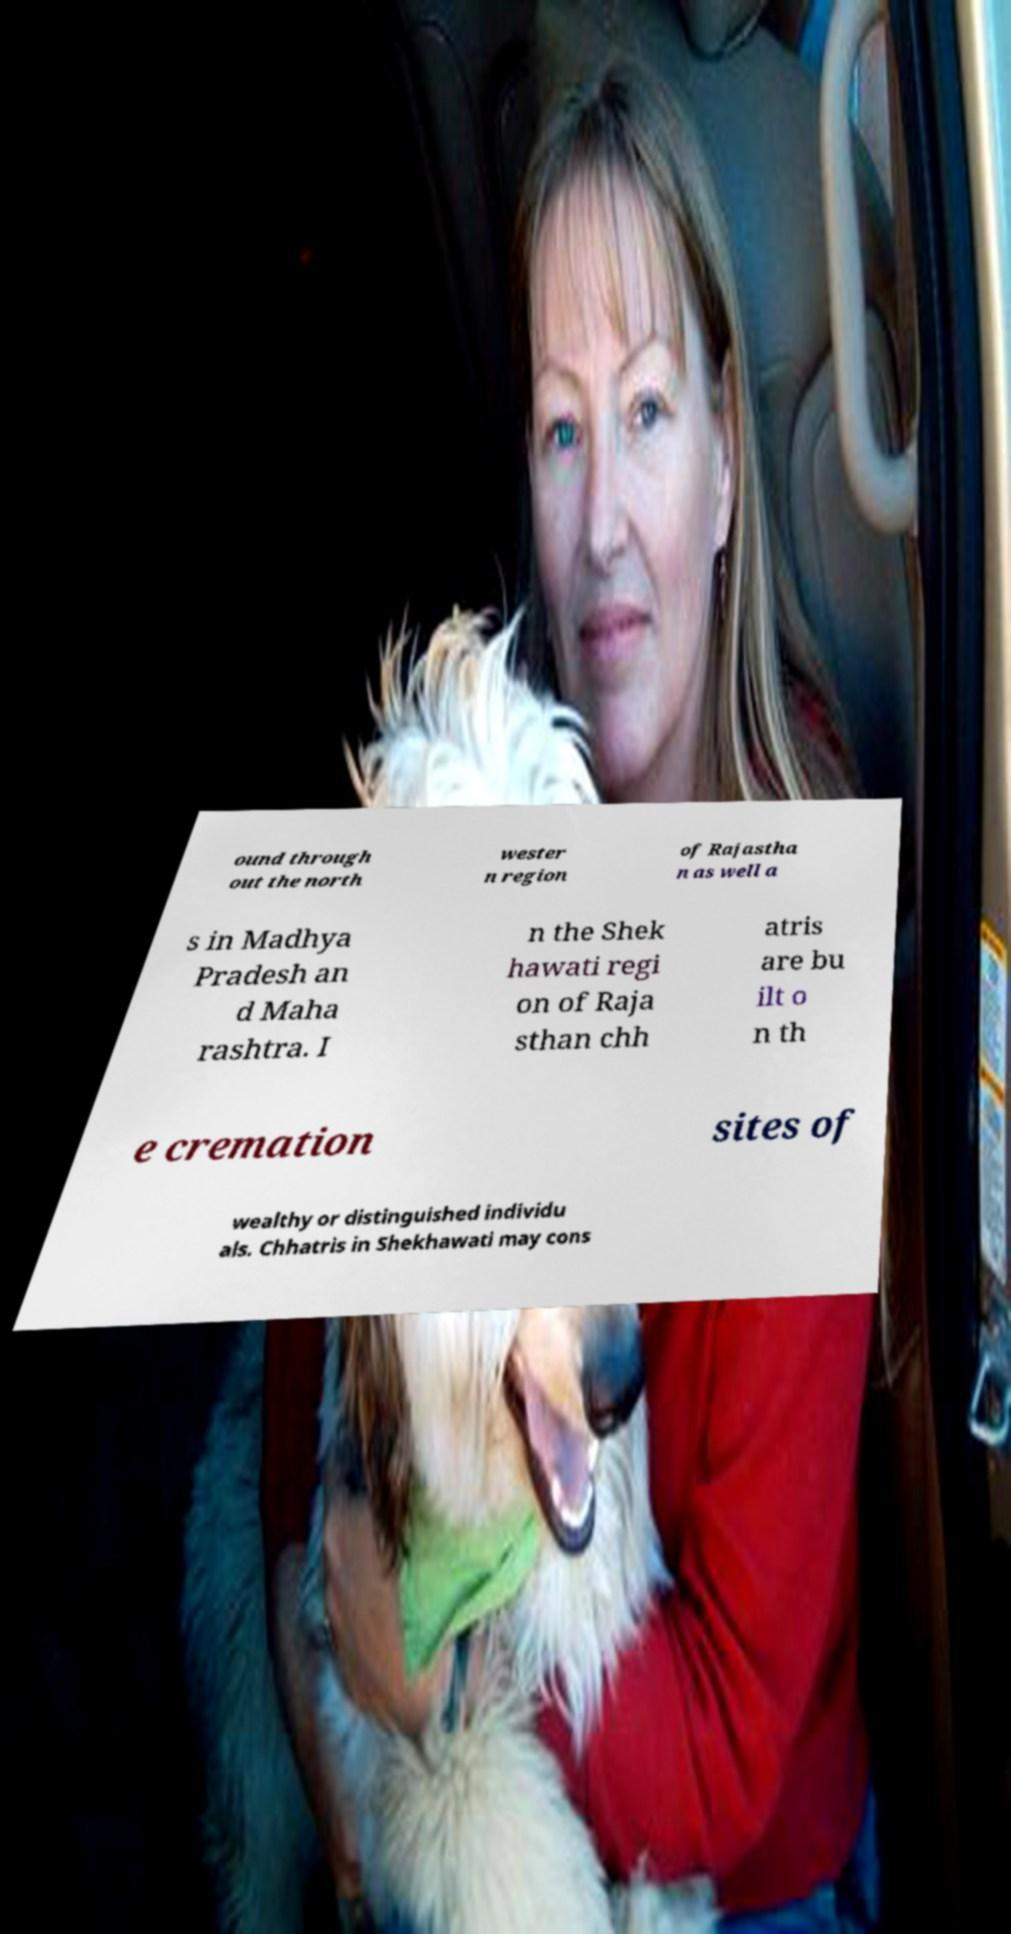Can you accurately transcribe the text from the provided image for me? ound through out the north wester n region of Rajastha n as well a s in Madhya Pradesh an d Maha rashtra. I n the Shek hawati regi on of Raja sthan chh atris are bu ilt o n th e cremation sites of wealthy or distinguished individu als. Chhatris in Shekhawati may cons 